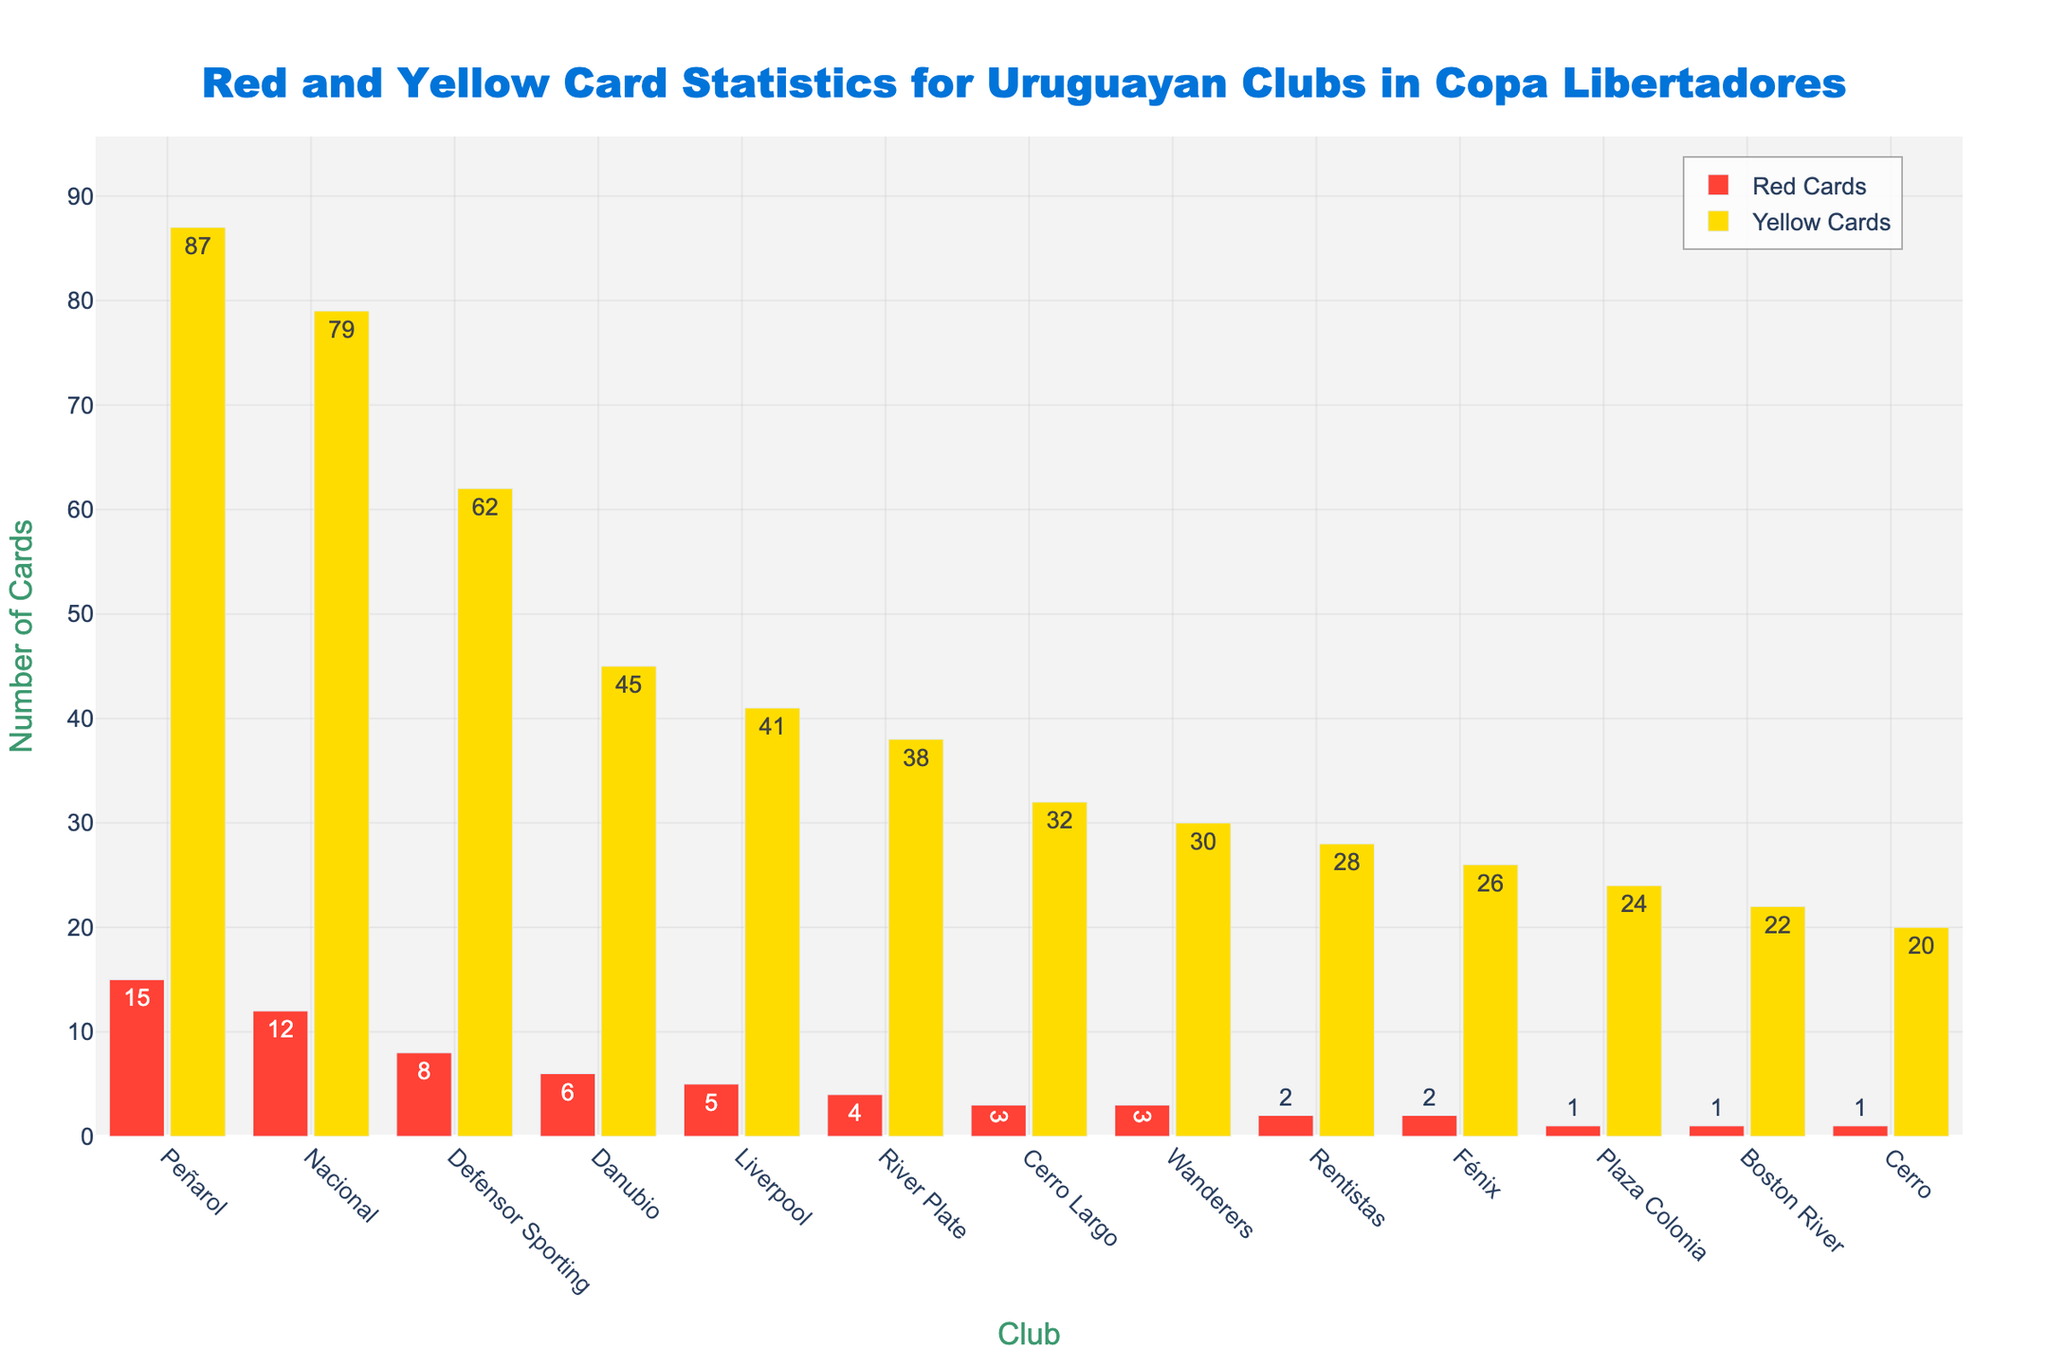Which club received the most red cards? Looking at the figure, the highest bar in the red category represents the club with the most red cards. Peñarol has the highest red bar at 15.
Answer: Peñarol How many yellow cards did Nacional and Defensor Sporting receive combined? The yellow cards for Nacional (79) and Defensor Sporting (62) are summed up: 79 + 62 = 141.
Answer: 141 Which club received fewer yellow cards, River Plate or Cerro Largo? By comparing the yellow bars for River Plate (38) and Cerro Largo (32), Cerro Largo has fewer yellow cards.
Answer: Cerro Largo What's the total number of red cards received by Danubio, Liverpool, and Rentistas combined? The red cards for Danubio (6), Liverpool (5), and Rentistas (2) are summed up: 6 + 5 + 2 = 13.
Answer: 13 Which club received more total cards (red + yellow), Fénix or Boston River? Calculating total cards for each: Fénix (2 red + 26 yellow = 28 total) and Boston River (1 red + 22 yellow = 23 total). Fénix has more total cards.
Answer: Fénix What's the average number of yellow cards received by the top three clubs with the most yellow cards? The top three clubs by yellow cards are Peñarol (87), Nacional (79), and Defensor Sporting (62). The average is (87 + 79 + 62) / 3 = 76.
Answer: 76 How many more yellow cards did Peñarol receive compared to Wanderers? Subtracting Wanderers' yellow cards (30) from Peñarol's yellow cards (87): 87 - 30 = 57.
Answer: 57 Which club has the tallest bar in the red category, and what does it represent? The tallest bar in the red category belongs to Peñarol, representing 15 red cards.
Answer: Peñarol, 15 red cards 